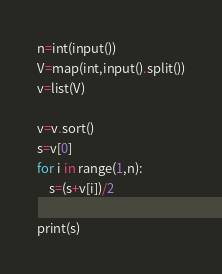<code> <loc_0><loc_0><loc_500><loc_500><_Python_>n=int(input())
V=map(int,input().split())
v=list(V)

v=v.sort()
s=v[0]
for i in range(1,n):
    s=(s+v[i])/2

print(s)
</code> 